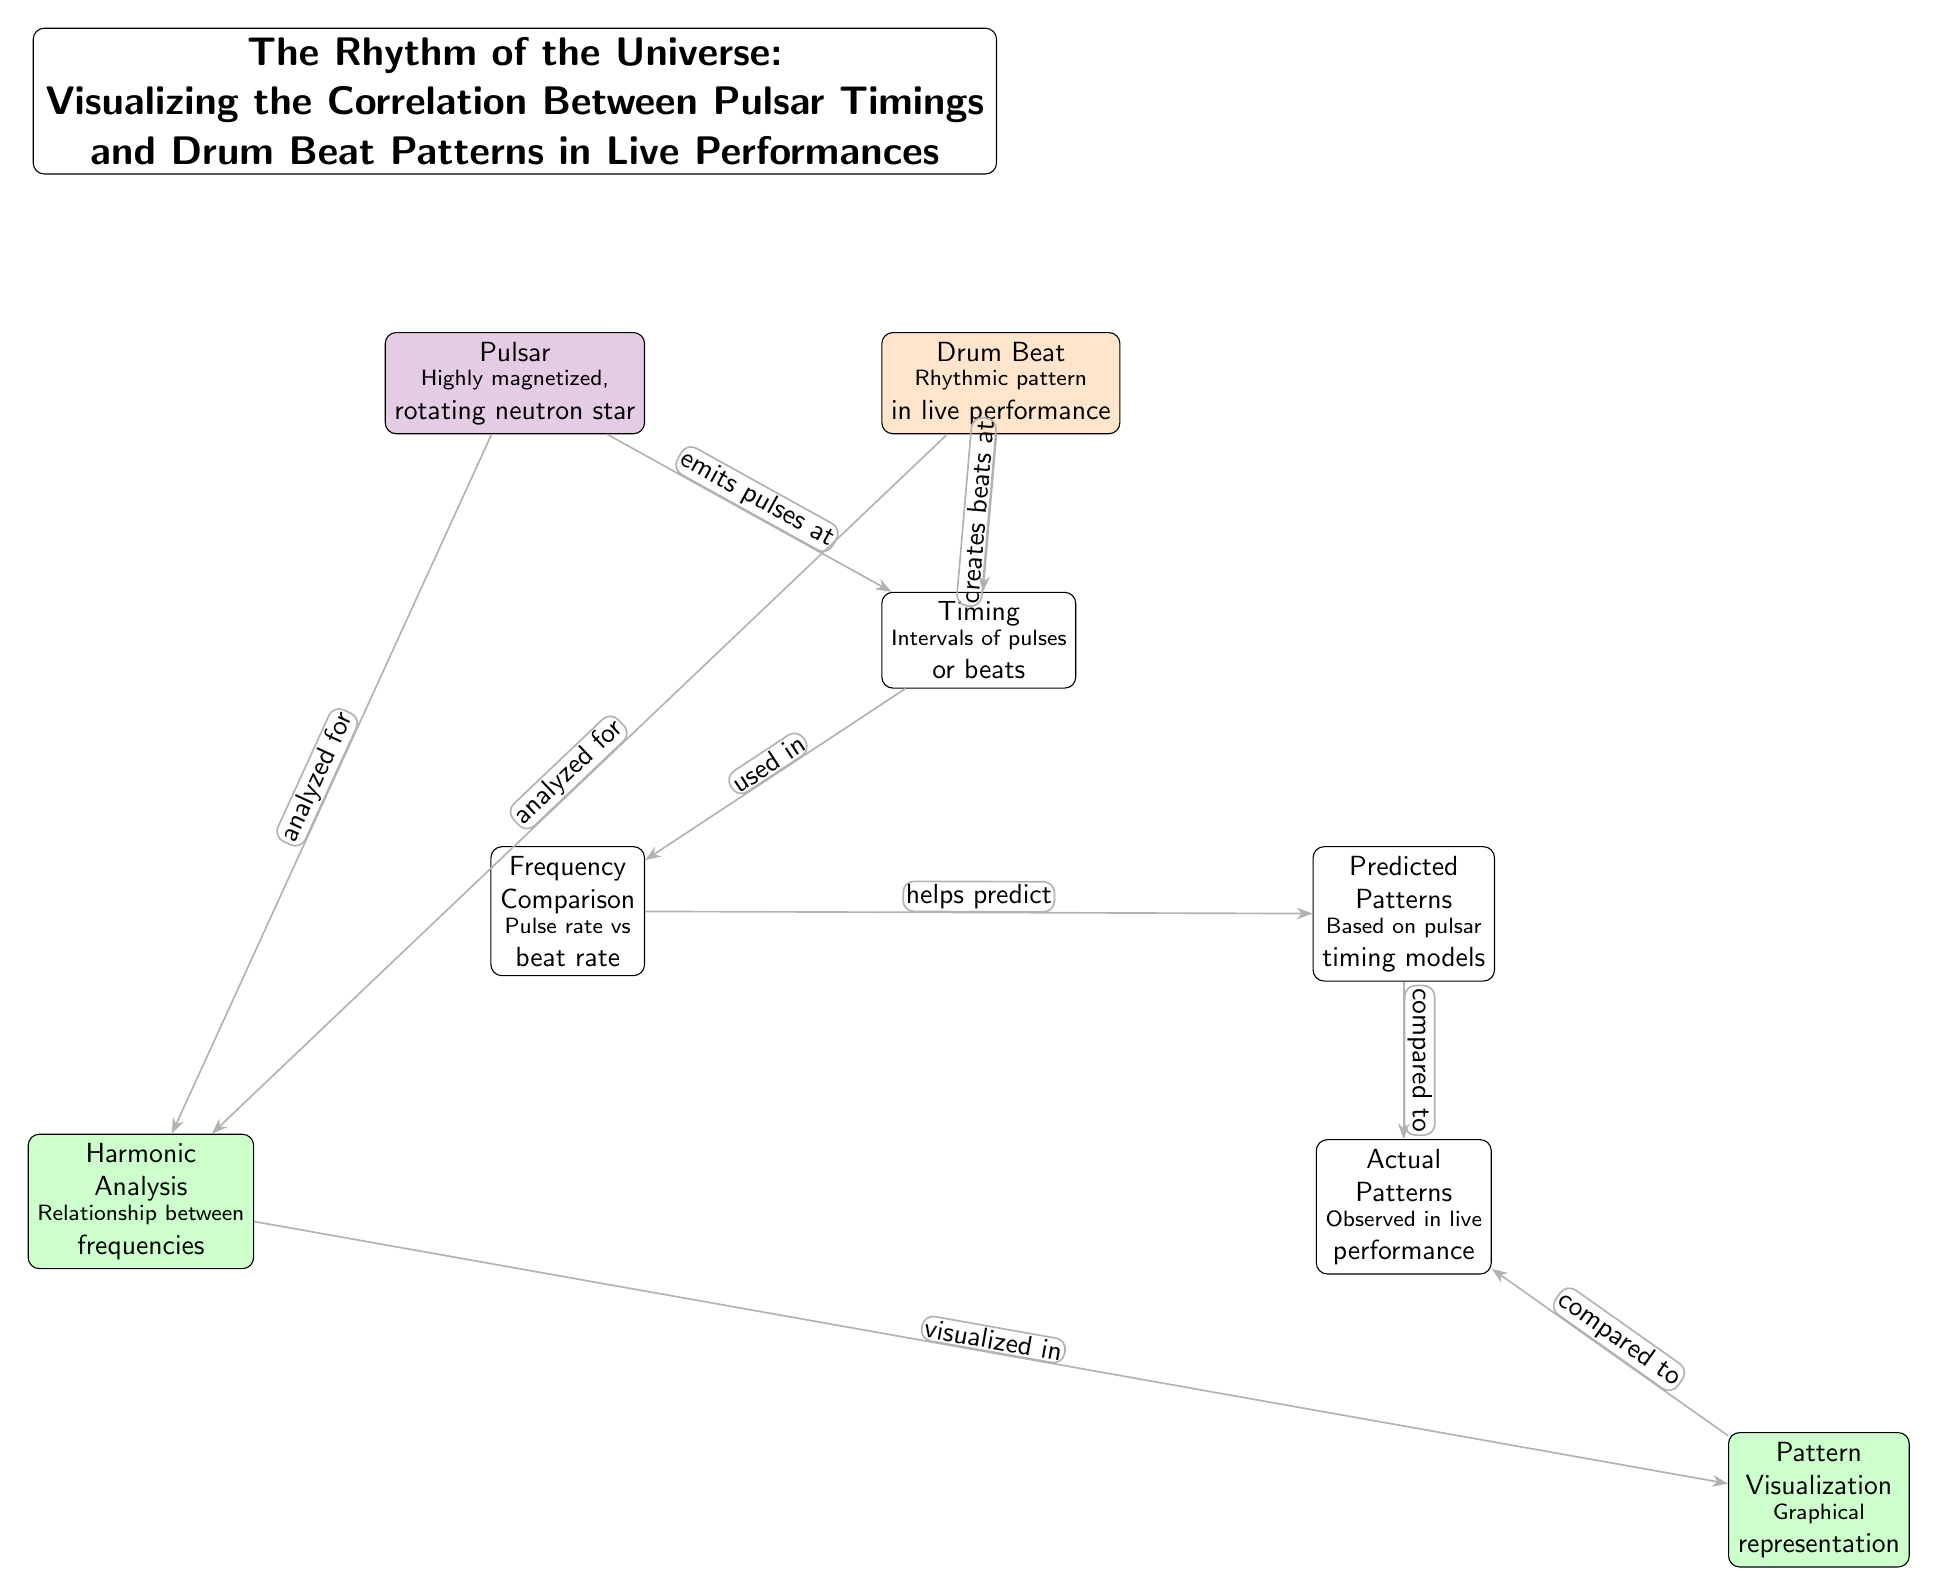What is the type of the object represented by the node labeled "Pulsar"? The node labeled "Pulsar" describes a highly magnetized, rotating neutron star, which is explicitly mentioned in the footnote of the node.
Answer: Highly magnetized, rotating neutron star What does the node labeled "Drum Beat" represent? The "Drum Beat" node represents a rhythmic pattern in live performance, as specified in its description.
Answer: Rhythmic pattern in live performance How many nodes are present in the diagram? Counting each labeled node and considering the relevant nodes, there are a total of 8 distinct nodes in the diagram.
Answer: 8 Which node is analyzed for harmonic analysis? Both the "Pulsar" and "Drum Beat" nodes are analyzed for harmonic analysis, which is indicated by directed edges leading to the "Harmonic Analysis" node.
Answer: Pulsar and Drum Beat What aspect does the arrow labeled "helps predict" connect? The "helps predict" arrow connects the "Frequency Comparison" node and the "Predicted Patterns" node, highlighting the relationship between comparing pulse rate and beat rate for prediction.
Answer: Frequency Comparison to Predicted Patterns Which node describes the observed patterns in live performances? The "Actual Patterns" node describes the observed patterns in live performances, as stated in its label and description.
Answer: Actual Patterns What is the relationship illustrated by the "compared to" edge? The "compared to" edge illustrates the relationship between the "Predicted Patterns" node and the "Actual Patterns" node, indicating that predicted outcomes are being compared against what is observed.
Answer: Predicted Patterns to Actual Patterns What visual representation method is used in the "Pattern Visualization" node? The "Pattern Visualization" node denotes that graphical representation is used, as defined in the description under this node.
Answer: Graphical representation 